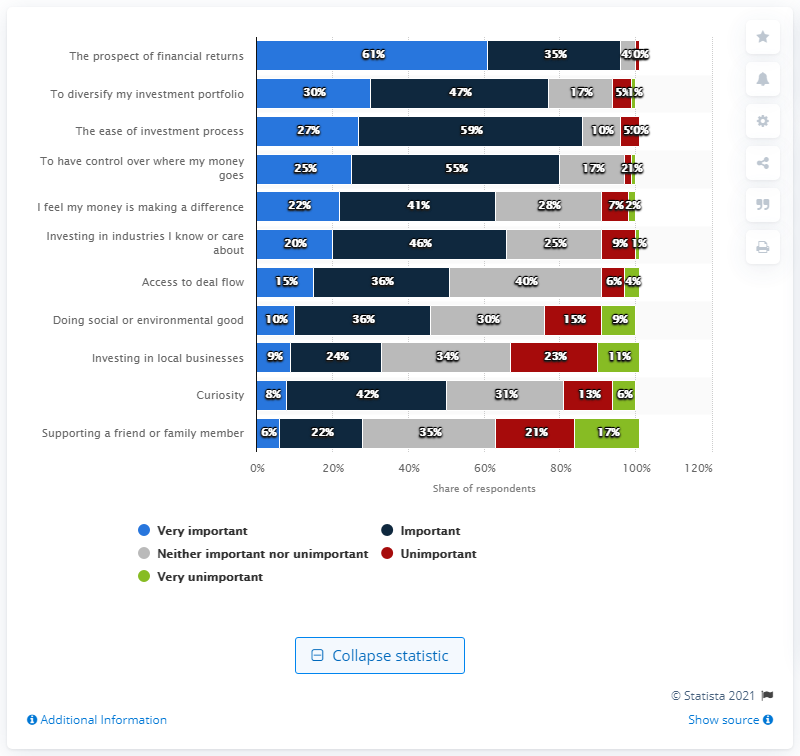Give some essential details in this illustration. The average of all the "very important" segments is 21.18. The answer with the largest value is the most important at 61%. 